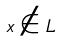<formula> <loc_0><loc_0><loc_500><loc_500>x \notin L</formula> 